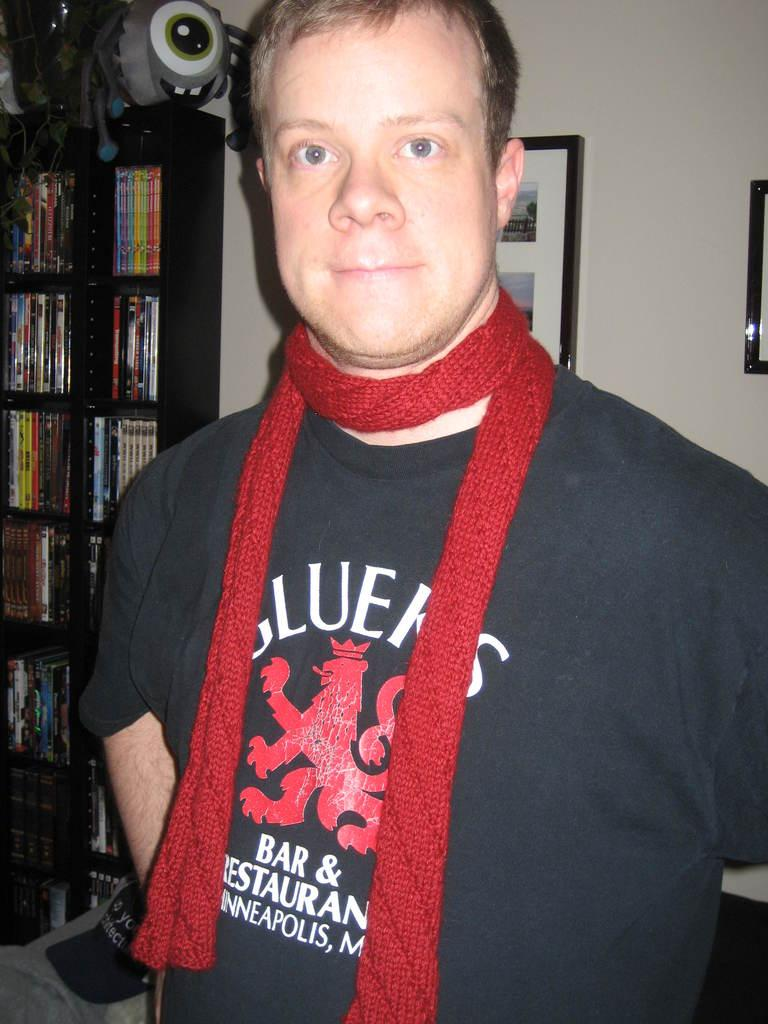<image>
Provide a brief description of the given image. A man in a red scard with the word bar and restaurant on his tee shirt 